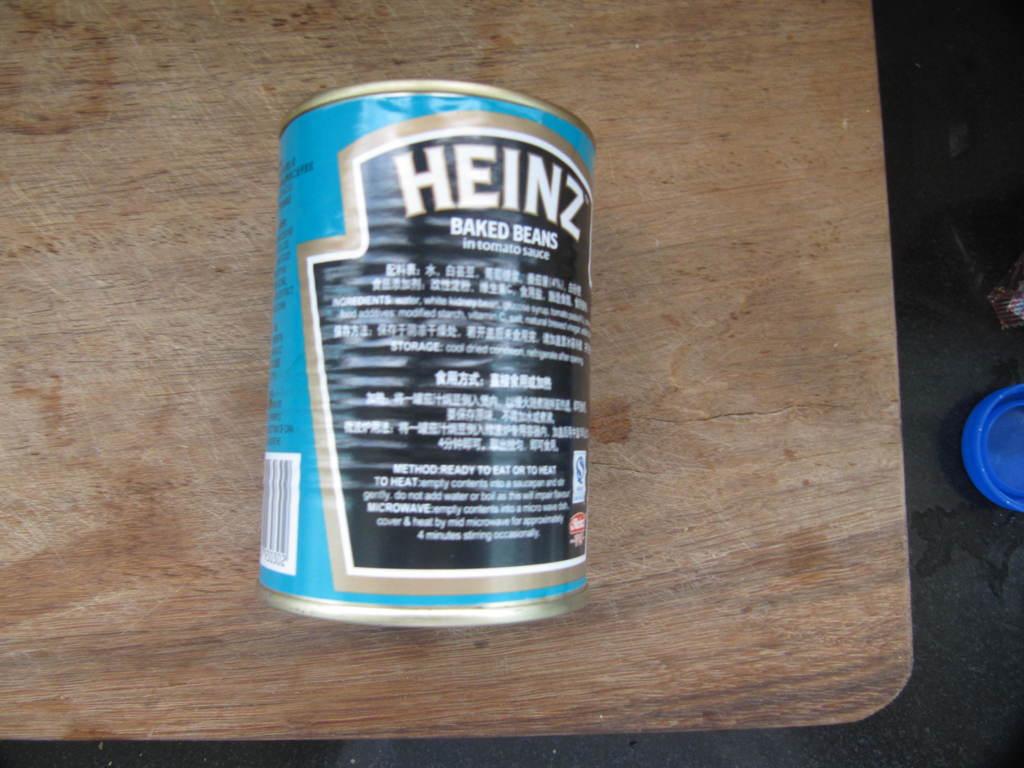What brand is this?
Provide a succinct answer. Heinz. 